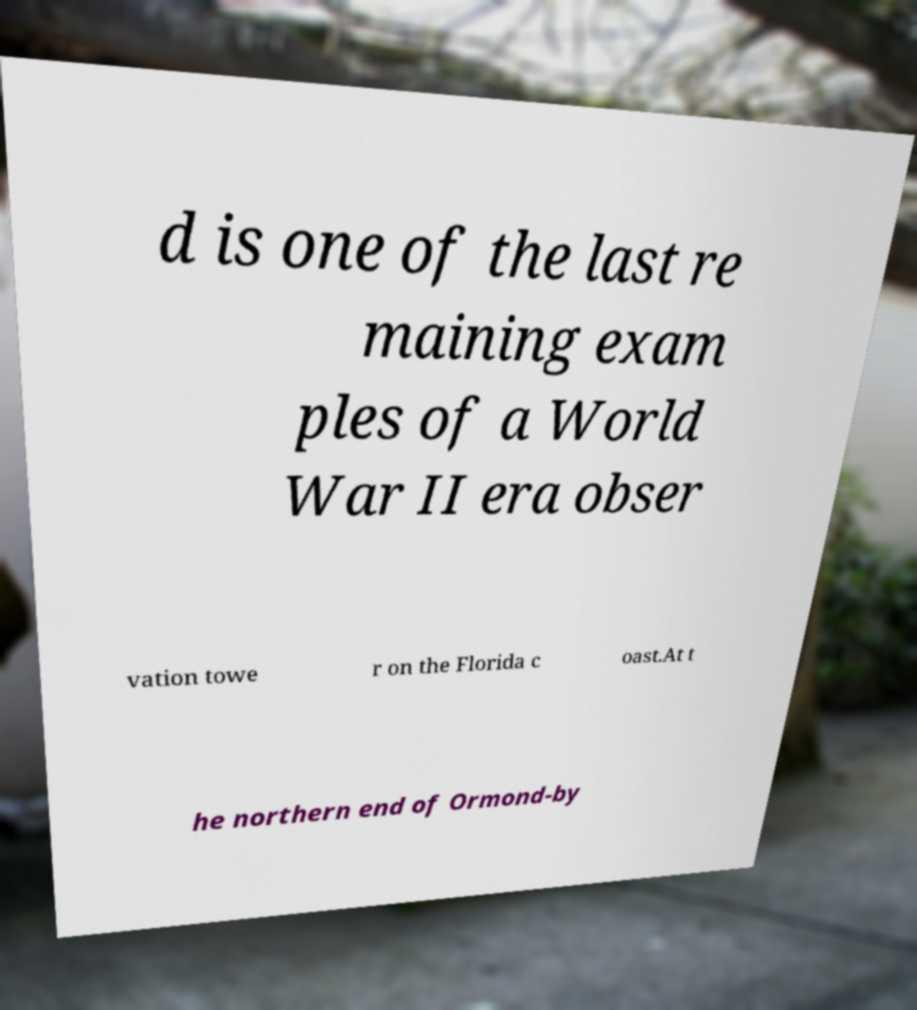Please identify and transcribe the text found in this image. d is one of the last re maining exam ples of a World War II era obser vation towe r on the Florida c oast.At t he northern end of Ormond-by 